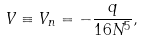<formula> <loc_0><loc_0><loc_500><loc_500>V \equiv V _ { n } = - \frac { q } { 1 6 N ^ { 5 } } ,</formula> 